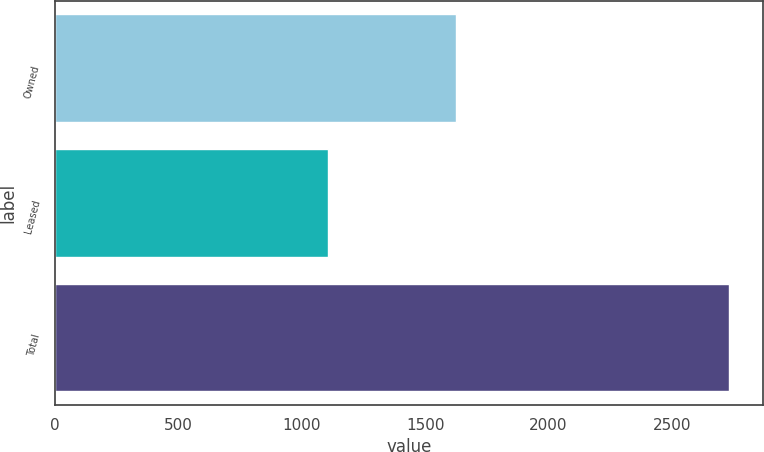Convert chart. <chart><loc_0><loc_0><loc_500><loc_500><bar_chart><fcel>Owned<fcel>Leased<fcel>Total<nl><fcel>1624<fcel>1107<fcel>2731<nl></chart> 